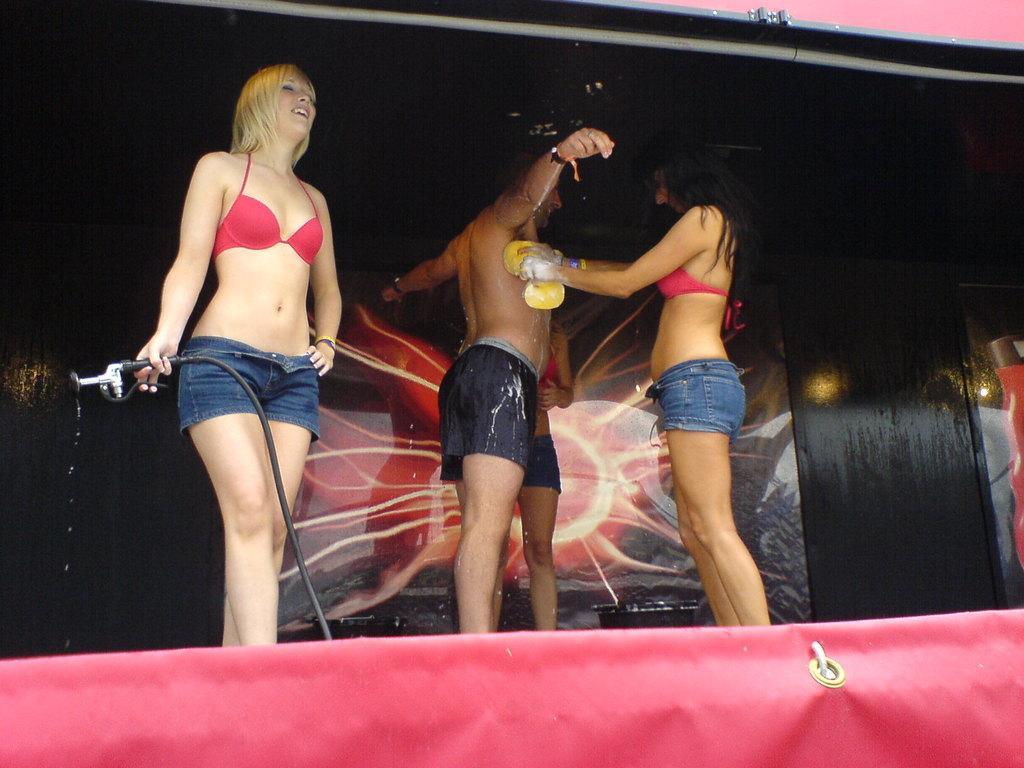Please provide a concise description of this image. In the image there are four people,three women and a man one of the woman is washing the man's body and another woman is holding a pipe with her hand,there is some poster in the background. 